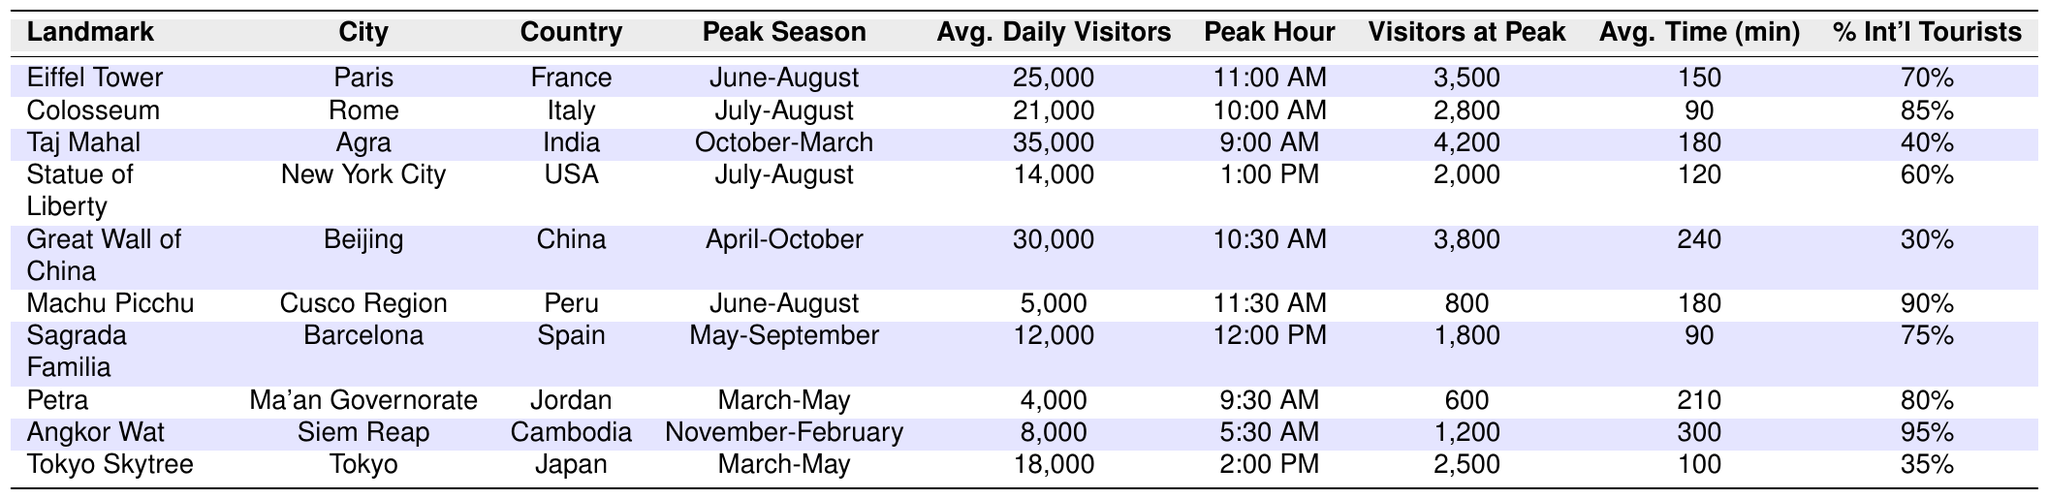What is the average daily number of visitors to the Taj Mahal? According to the table, the average daily visitors to the Taj Mahal is listed as 35,000.
Answer: 35,000 Which landmark has the highest percentage of international tourists? The table shows that Angkor Wat has the highest percentage of international tourists at 95%.
Answer: 95% What is the peak hour for visitor traffic at the Great Wall of China? The peak hour for visitor traffic at the Great Wall of China is recorded as 10:30 AM in the table.
Answer: 10:30 AM How many visitors are there on average during peak hour at the Eiffel Tower? The table indicates that the average number of visitors during peak hour at the Eiffel Tower is 3,500.
Answer: 3,500 Which two landmarks have an average time spent of 180 minutes? The Taj Mahal and Machu Picchu both have an average time spent of 180 minutes as per the table.
Answer: Taj Mahal and Machu Picchu If we consider the percentage of international tourists, which is the landmark with the lowest percentage? The landmark with the lowest percentage of international tourists is the Great Wall of China, which has 30%.
Answer: 30% What is the total average daily visitors for all landmarks in the table? The total average is calculated by summing the average daily visitors (25,000 + 21,000 + 35,000 + 14,000 + 30,000 + 5,000 + 12,000 + 4,000 + 8,000 + 18,000) = 168,000. Therefore, the total average daily visitors is 168,000.
Answer: 168,000 At which landmark do visitors spend the longest time on average? The table indicates that visitors spend the longest time on average at the Great Wall of China with 240 minutes.
Answer: 240 minutes Is the average daily visitor count at the Statue of Liberty greater than that at the Sagrada Familia? The average daily visitors of the Statue of Liberty (14,000) is greater than that of the Sagrada Familia (12,000), which makes the statement true.
Answer: Yes How many more visitors during peak hour does the Taj Mahal receive compared to Machu Picchu? The Taj Mahal receives 4,200 visitors during peak hour, while Machu Picchu has 800. The difference is 4,200 - 800 = 3,400.
Answer: 3,400 more visitors What is the peak time for visitors at the Statue of Liberty? The peak time for visitors at the Statue of Liberty is listed in the table as 1:00 PM.
Answer: 1:00 PM 